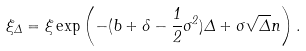Convert formula to latex. <formula><loc_0><loc_0><loc_500><loc_500>\xi _ { \Delta } = \xi \exp \left ( - ( b + \delta - \frac { 1 } { 2 } \sigma ^ { 2 } ) \Delta + \sigma \sqrt { \Delta } n \right ) .</formula> 